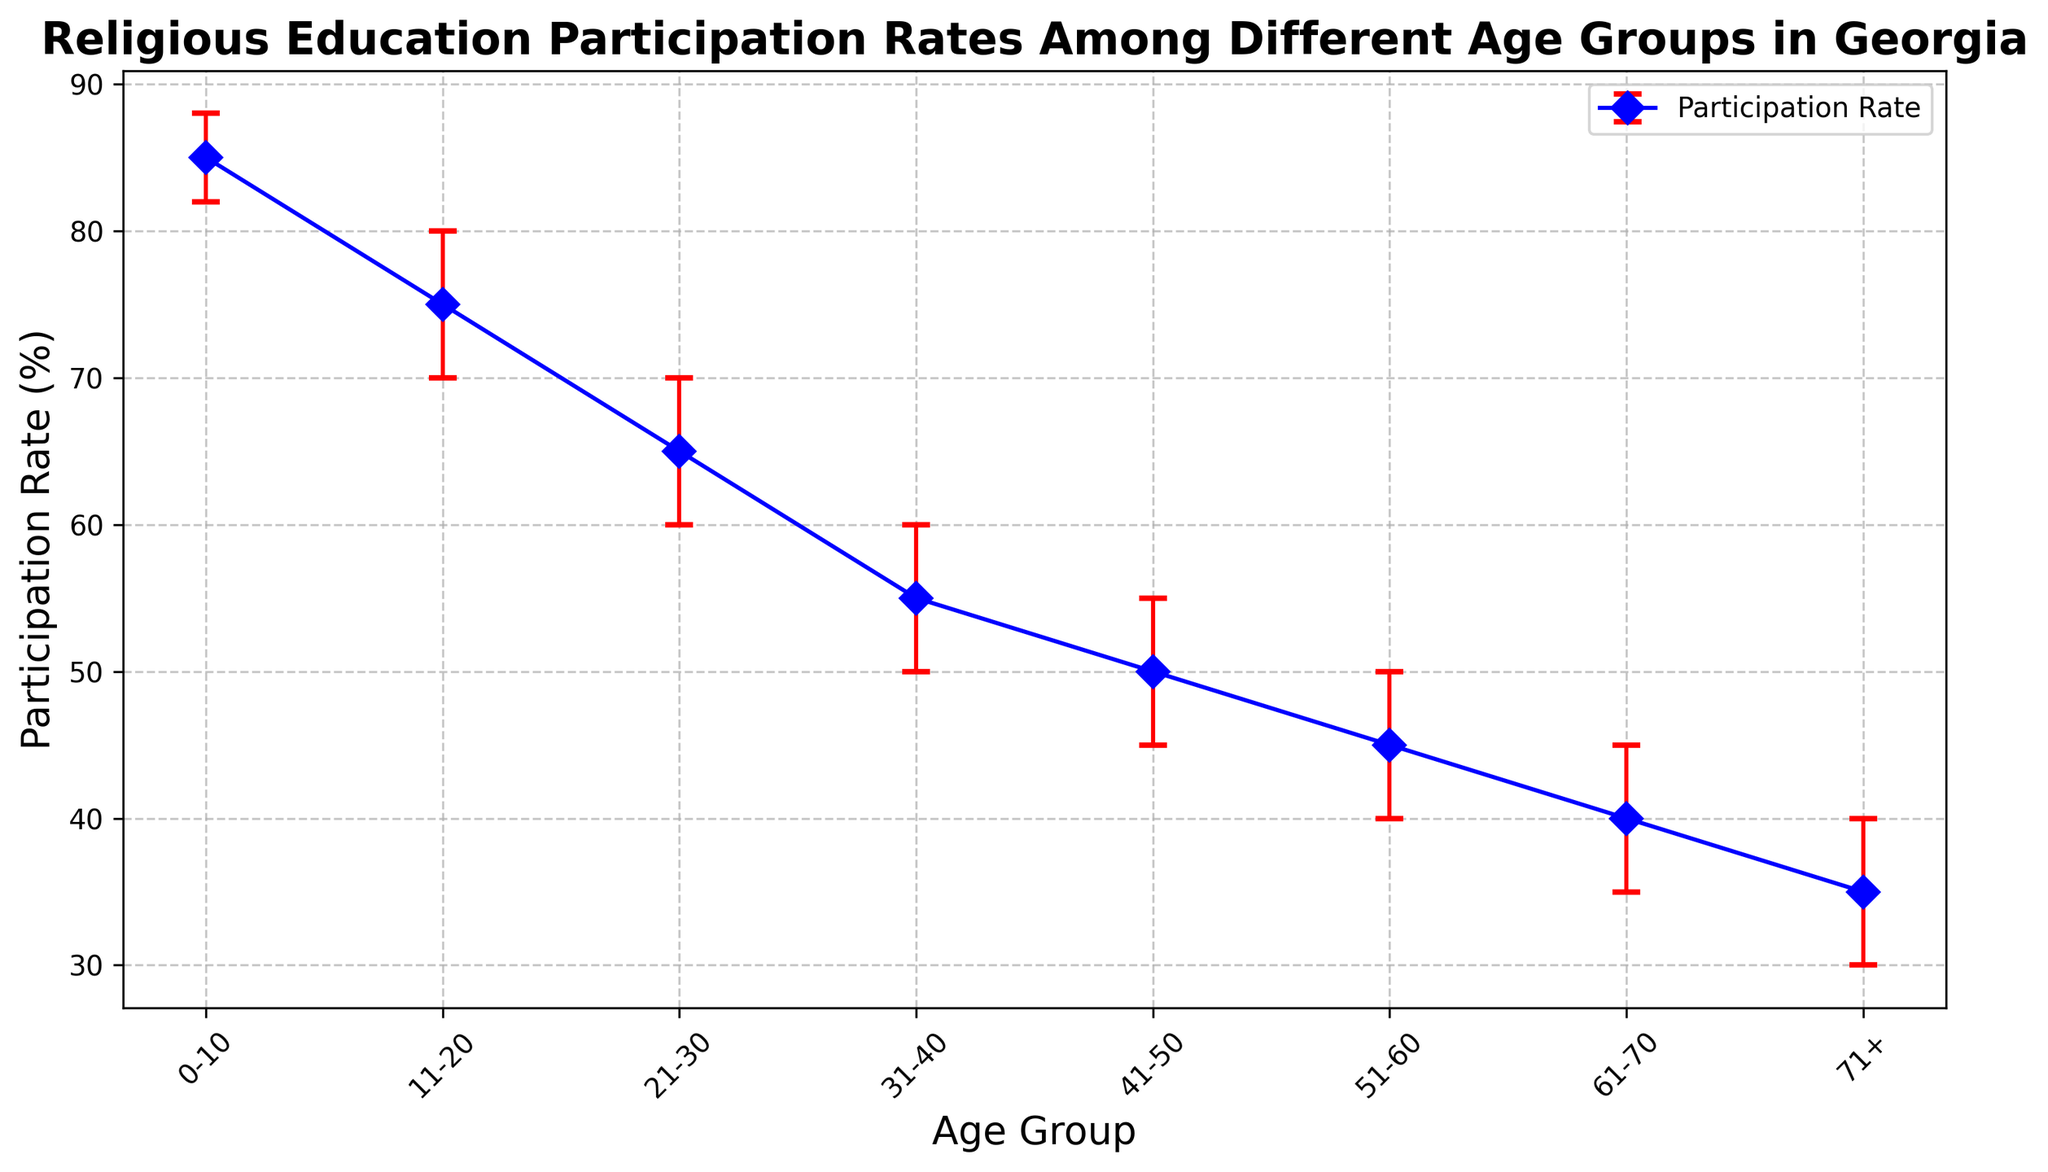What is the participation rate for the 31-40 age group? According to the figure, the participation rate for each age group is marked by a blue point. The blue point corresponding to the 31-40 age group is associated with the Y-axis value of 55%.
Answer: 55% Which age group has the highest participation rate? The highest point on the Y-axis indicates the highest participation rate. The topmost blue point corresponds to the 0-10 age group, with a participation rate of 85%.
Answer: 0-10 What is the difference in participation rates between the 11-20 and 51-60 age groups? To find the difference in participation rates, subtract the lower number from the higher: 75% (for 11-20) - 45% (for 51-60) = 30%.
Answer: 30% Which age group has the largest confidence interval? Confidence intervals are represented by the length of the vertical red error bars. The longest error bar corresponds to the 11-20 age group, with a confidence interval that ranges from 70% to 80%, spanning 10 percentage points.
Answer: 11-20 What is the average participation rate of the age groups 21-30, 31-40, and 41-50? The participation rates are 65% (21-30), 55% (31-40), and 50% (41-50). Their average is calculated as (65 + 55 + 50) / 3 = 170 / 3 ≈ 56.67%.
Answer: 56.67% Is the participation rate for the 71+ age group greater than or less than the rate for the 41-50 age group? The participation rate for the 71+ age group is 35%, while the rate for the 41-50 age group is 50%. Therefore, 35% is less than 50%.
Answer: Less than Which age groups have participation rates that are equal to or above 50%? From the figure, the age groups with participation rates at or above 50% are 0-10 (85%), 11-20 (75%), 21-30 (65%), 31-40 (55%), and 41-50 (50%).
Answer: 0-10, 11-20, 21-30, 31-40, 41-50 What is the median participation rate among all age groups? The participation rates, listed in ascending order, are: 35%, 40%, 45%, 50%, 55%, 65%, 75%, 85%. The median, being the average of the middle two values (50% and 55%), is (50 + 55) / 2 = 52.5%.
Answer: 52.5% 